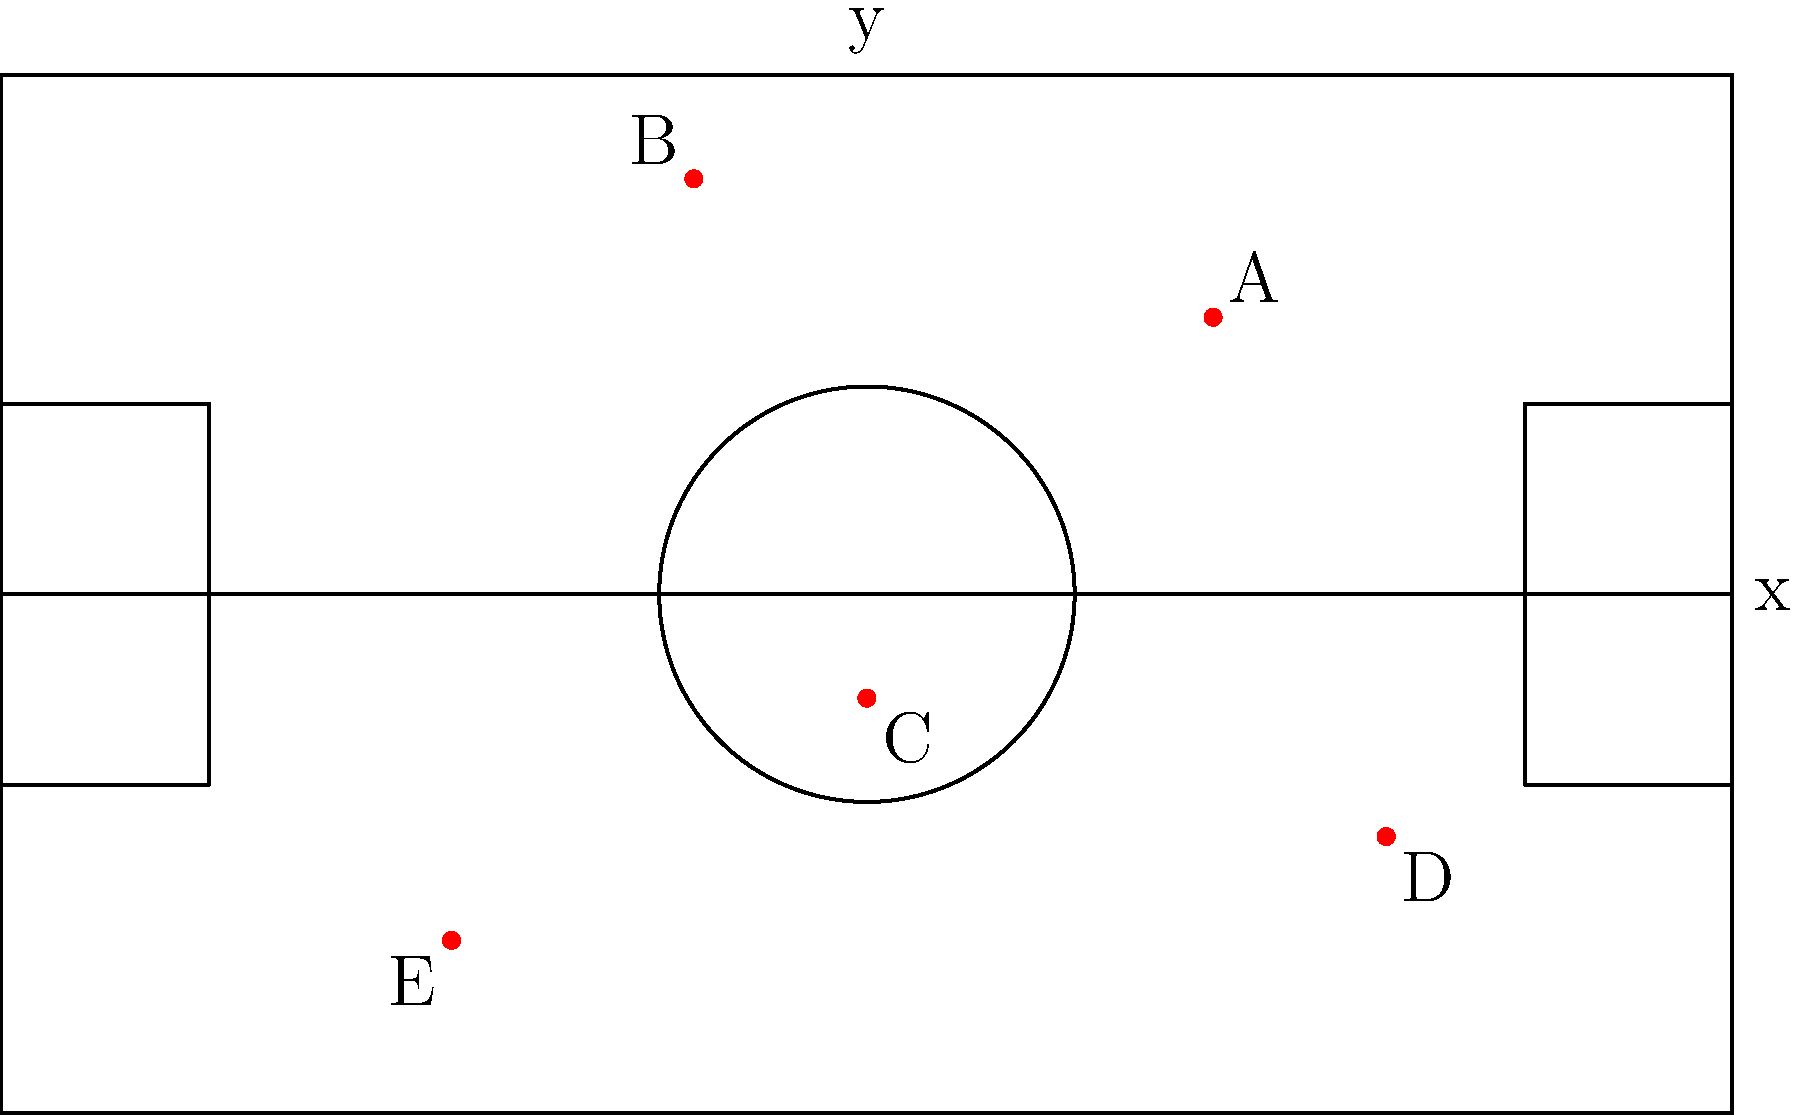In the diagram above, Notre Dame's offensive plays are represented by red dots on a coordinate system overlaid on a basketball court. Which play (represented by points A, B, C, D, or E) is closest to the center of the three-point line on the right side of the court, located at coordinates (19, 0)? To determine which point is closest to (19, 0), we need to calculate the distance between each point and (19, 0) using the distance formula:

$d = \sqrt{(x_2 - x_1)^2 + (y_2 - y_1)^2}$

Let's calculate the distance for each point:

1. Point A (10, 8):
   $d_A = \sqrt{(19 - 10)^2 + (0 - 8)^2} = \sqrt{81 + 64} = \sqrt{145} \approx 12.04$

2. Point B (-5, 12):
   $d_B = \sqrt{(19 - (-5))^2 + (0 - 12)^2} = \sqrt{576 + 144} = \sqrt{720} \approx 26.83$

3. Point C (0, -3):
   $d_C = \sqrt{(19 - 0)^2 + (0 - (-3))^2} = \sqrt{361 + 9} = \sqrt{370} \approx 19.24$

4. Point D (15, -7):
   $d_D = \sqrt{(19 - 15)^2 + (0 - (-7))^2} = \sqrt{16 + 49} = \sqrt{65} \approx 8.06$

5. Point E (-12, -10):
   $d_E = \sqrt{(19 - (-12))^2 + (0 - (-10))^2} = \sqrt{961 + 100} = \sqrt{1061} \approx 32.57$

The point with the smallest distance to (19, 0) is the closest. From our calculations, we can see that Point D has the smallest distance of approximately 8.06.
Answer: D 